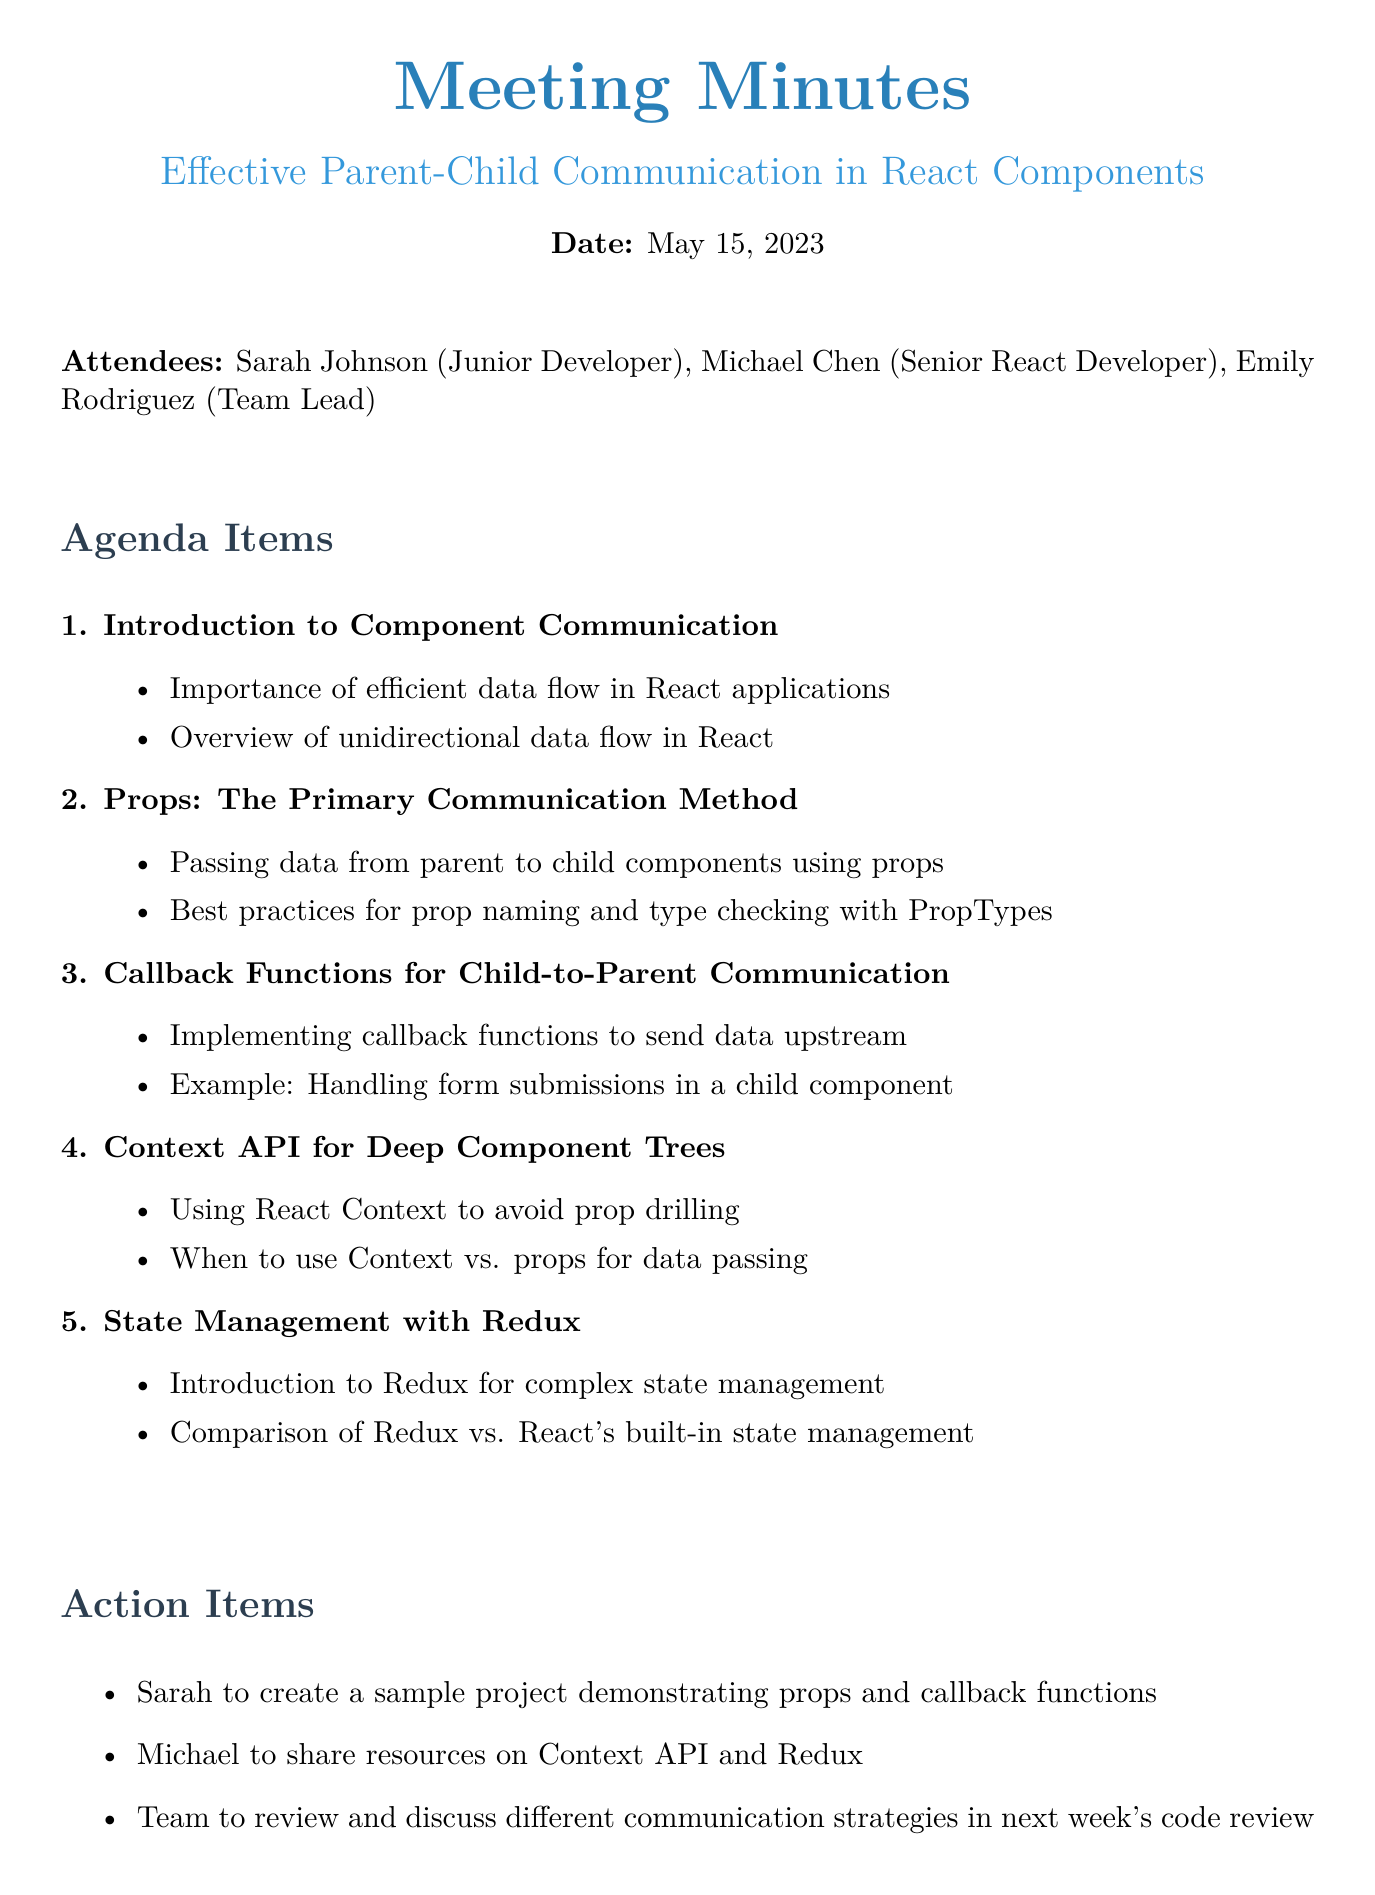What is the date of the meeting? The date of the meeting is explicitly mentioned in the document.
Answer: May 15, 2023 Who is the Team Lead? The document lists the attendees, including their roles.
Answer: Emily Rodriguez What is the primary communication method discussed? The agenda items outline various communication methods, highlighting the primary one for this meeting.
Answer: Props What action item is assigned to Sarah? The action items specify tasks assigned to each participant.
Answer: Create a sample project demonstrating props and callback functions What is one resource mentioned in the meeting minutes? The resources section lists various useful materials related to the meeting topics.
Answer: React official documentation What is the purpose of the Context API as discussed in the meeting? The agenda points provide insight into the benefits of using Context API in certain scenarios.
Answer: Avoid prop drilling How many attendees were present? The attendees list provides the total count of participants in the meeting.
Answer: Three What comparison is made in the meeting minutes? The agenda items include comparisons between different state management techniques in React.
Answer: Redux vs. React's built-in state management What is the first agenda item discussed? The document outlines the agenda items in a sequential order.
Answer: Introduction to Component Communication 